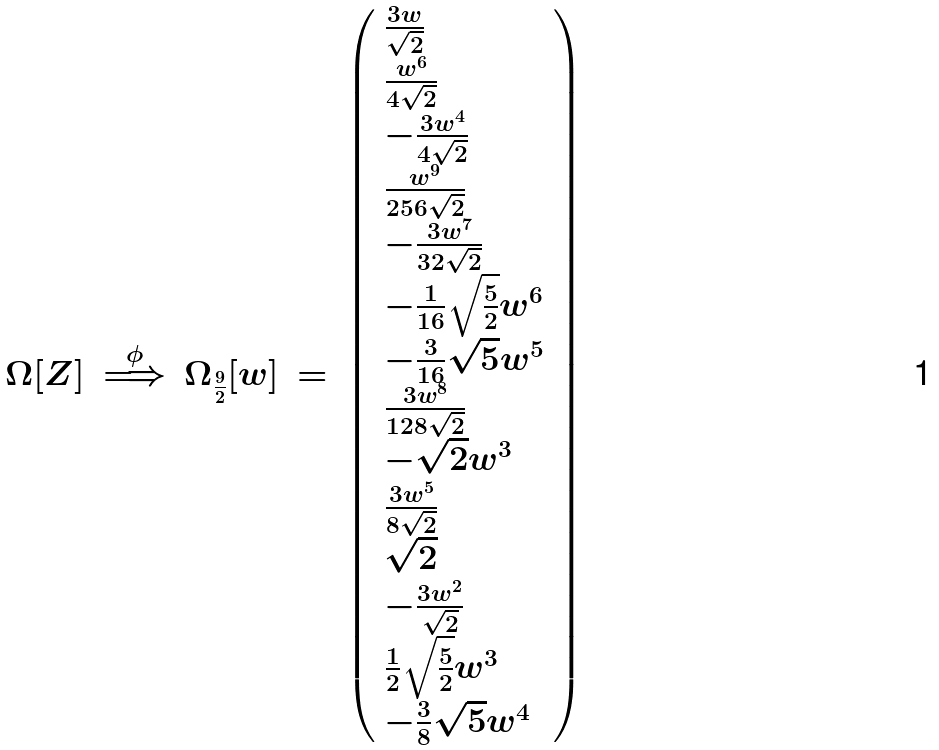Convert formula to latex. <formula><loc_0><loc_0><loc_500><loc_500>\Omega [ Z ] \, \stackrel { \phi } { \Longrightarrow } \, \Omega _ { \frac { 9 } { 2 } } [ w ] \, = \, \left ( \begin{array} { l } \frac { 3 w } { \sqrt { 2 } } \\ \frac { w ^ { 6 } } { 4 \sqrt { 2 } } \\ - \frac { 3 w ^ { 4 } } { 4 \sqrt { 2 } } \\ \frac { w ^ { 9 } } { 2 5 6 \sqrt { 2 } } \\ - \frac { 3 w ^ { 7 } } { 3 2 \sqrt { 2 } } \\ - \frac { 1 } { 1 6 } \sqrt { \frac { 5 } { 2 } } w ^ { 6 } \\ - \frac { 3 } { 1 6 } \sqrt { 5 } w ^ { 5 } \\ \frac { 3 w ^ { 8 } } { 1 2 8 \sqrt { 2 } } \\ - \sqrt { 2 } w ^ { 3 } \\ \frac { 3 w ^ { 5 } } { 8 \sqrt { 2 } } \\ \sqrt { 2 } \\ - \frac { 3 w ^ { 2 } } { \sqrt { 2 } } \\ \frac { 1 } { 2 } \sqrt { \frac { 5 } { 2 } } w ^ { 3 } \\ - \frac { 3 } { 8 } \sqrt { 5 } w ^ { 4 } \end{array} \right )</formula> 